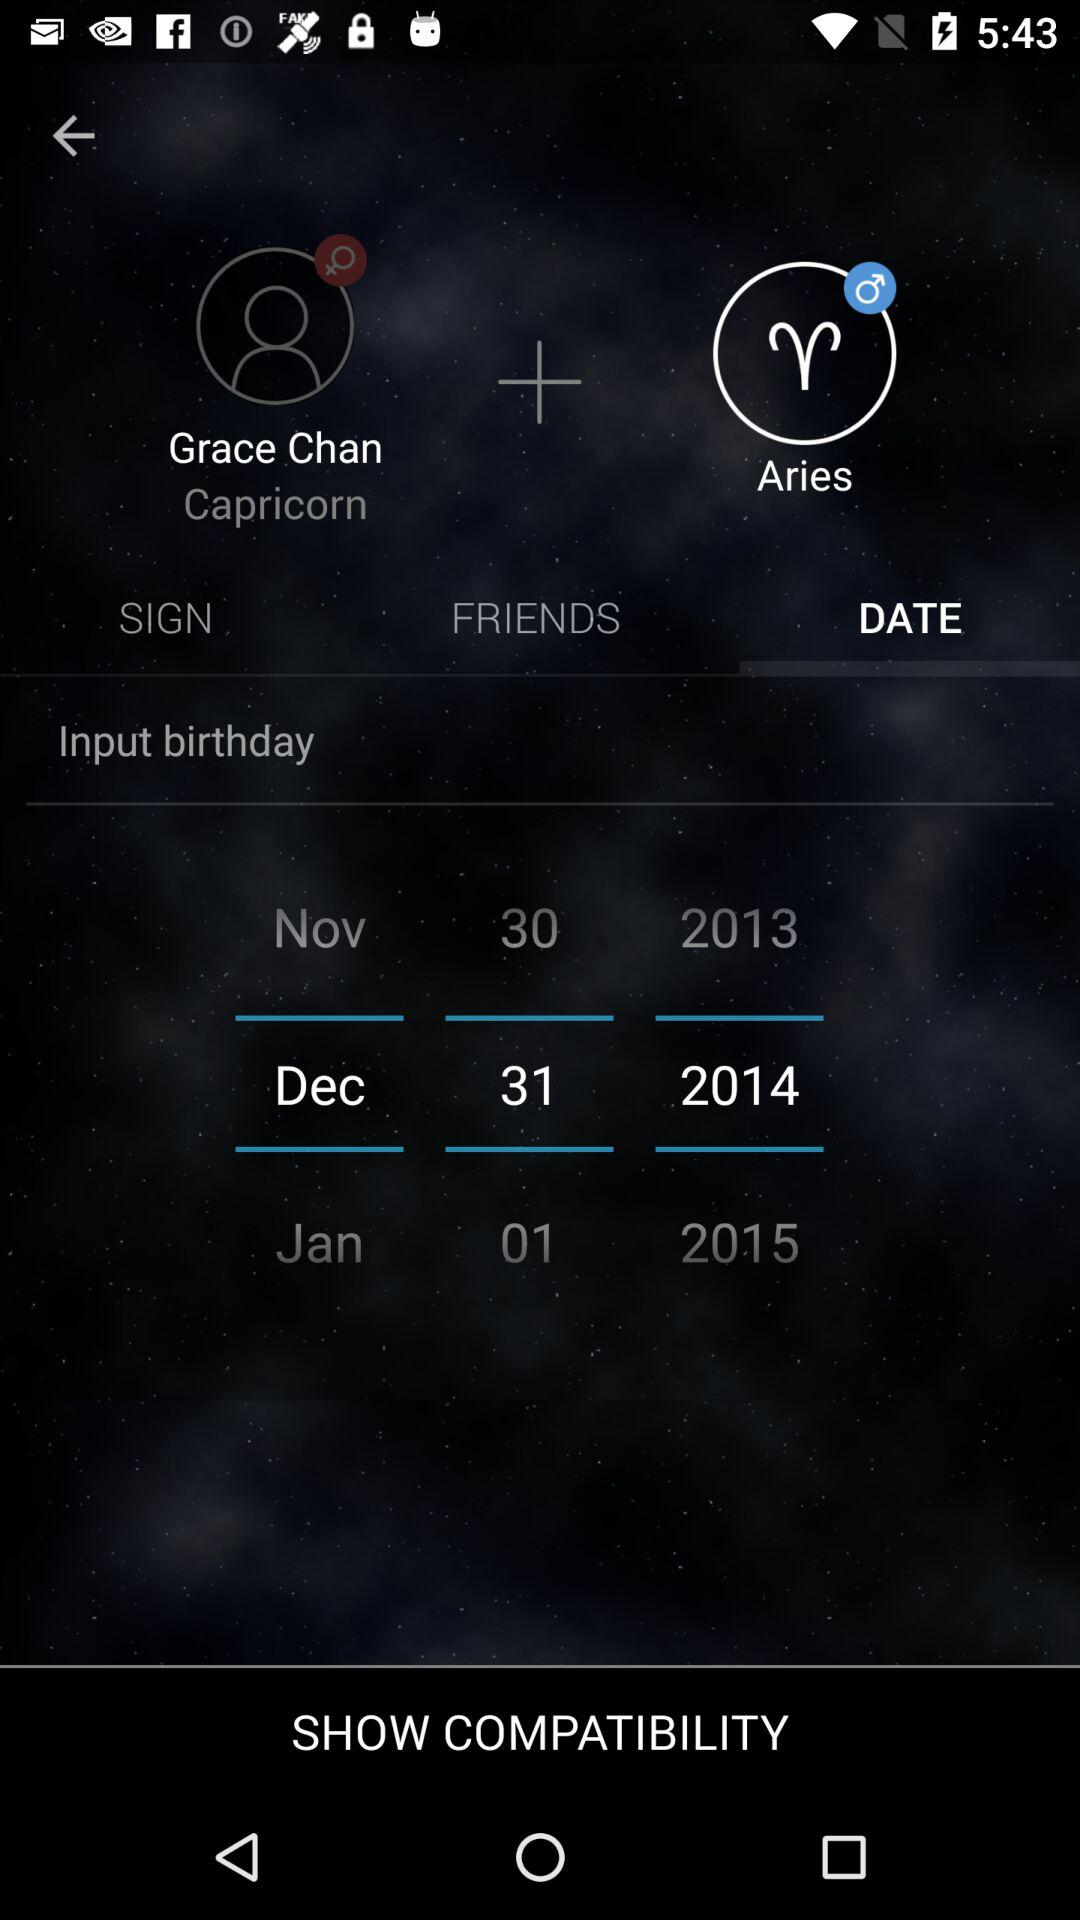What is the selected tab? The selected tab is "DATE". 